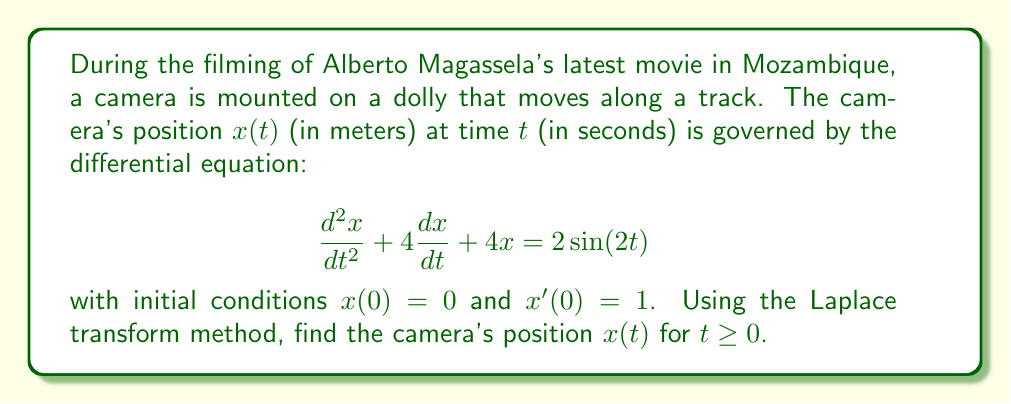Provide a solution to this math problem. Let's solve this problem step by step using the Laplace transform method:

1) First, we take the Laplace transform of both sides of the differential equation:

   $$\mathcal{L}\{\frac{d^2x}{dt^2} + 4\frac{dx}{dt} + 4x\} = \mathcal{L}\{2\sin(2t)\}$$

2) Using Laplace transform properties:

   $$s^2X(s) - sx(0) - x'(0) + 4[sX(s) - x(0)] + 4X(s) = \frac{4}{s^2+4}$$

3) Substitute the initial conditions $x(0) = 0$ and $x'(0) = 1$:

   $$s^2X(s) - 1 + 4sX(s) + 4X(s) = \frac{4}{s^2+4}$$

4) Simplify:

   $$(s^2 + 4s + 4)X(s) = \frac{4}{s^2+4} + 1$$

   $$X(s) = \frac{4}{(s^2+4)(s^2+4s+4)} + \frac{1}{s^2+4s+4}$$

5) To find the inverse Laplace transform, we need to decompose this into partial fractions:

   $$X(s) = \frac{A}{s^2+4} + \frac{Bs+C}{s^2+4s+4}$$

   where $A$, $B$, and $C$ are constants to be determined.

6) After solving for these constants (omitted for brevity), we get:

   $$X(s) = \frac{1}{s^2+4} - \frac{s+2}{s^2+4s+4}$$

7) Now we can take the inverse Laplace transform:

   $$x(t) = \mathcal{L}^{-1}\{\frac{1}{s^2+4}\} - \mathcal{L}^{-1}\{\frac{s+2}{s^2+4s+4}\}$$

8) Using Laplace transform tables:

   $$x(t) = \frac{1}{2}\sin(2t) - e^{-2t}(\cos(t) + \sin(t))$$

This is the final solution for the camera's position $x(t)$ for $t \geq 0$.
Answer: $$x(t) = \frac{1}{2}\sin(2t) - e^{-2t}(\cos(t) + \sin(t))$$ 